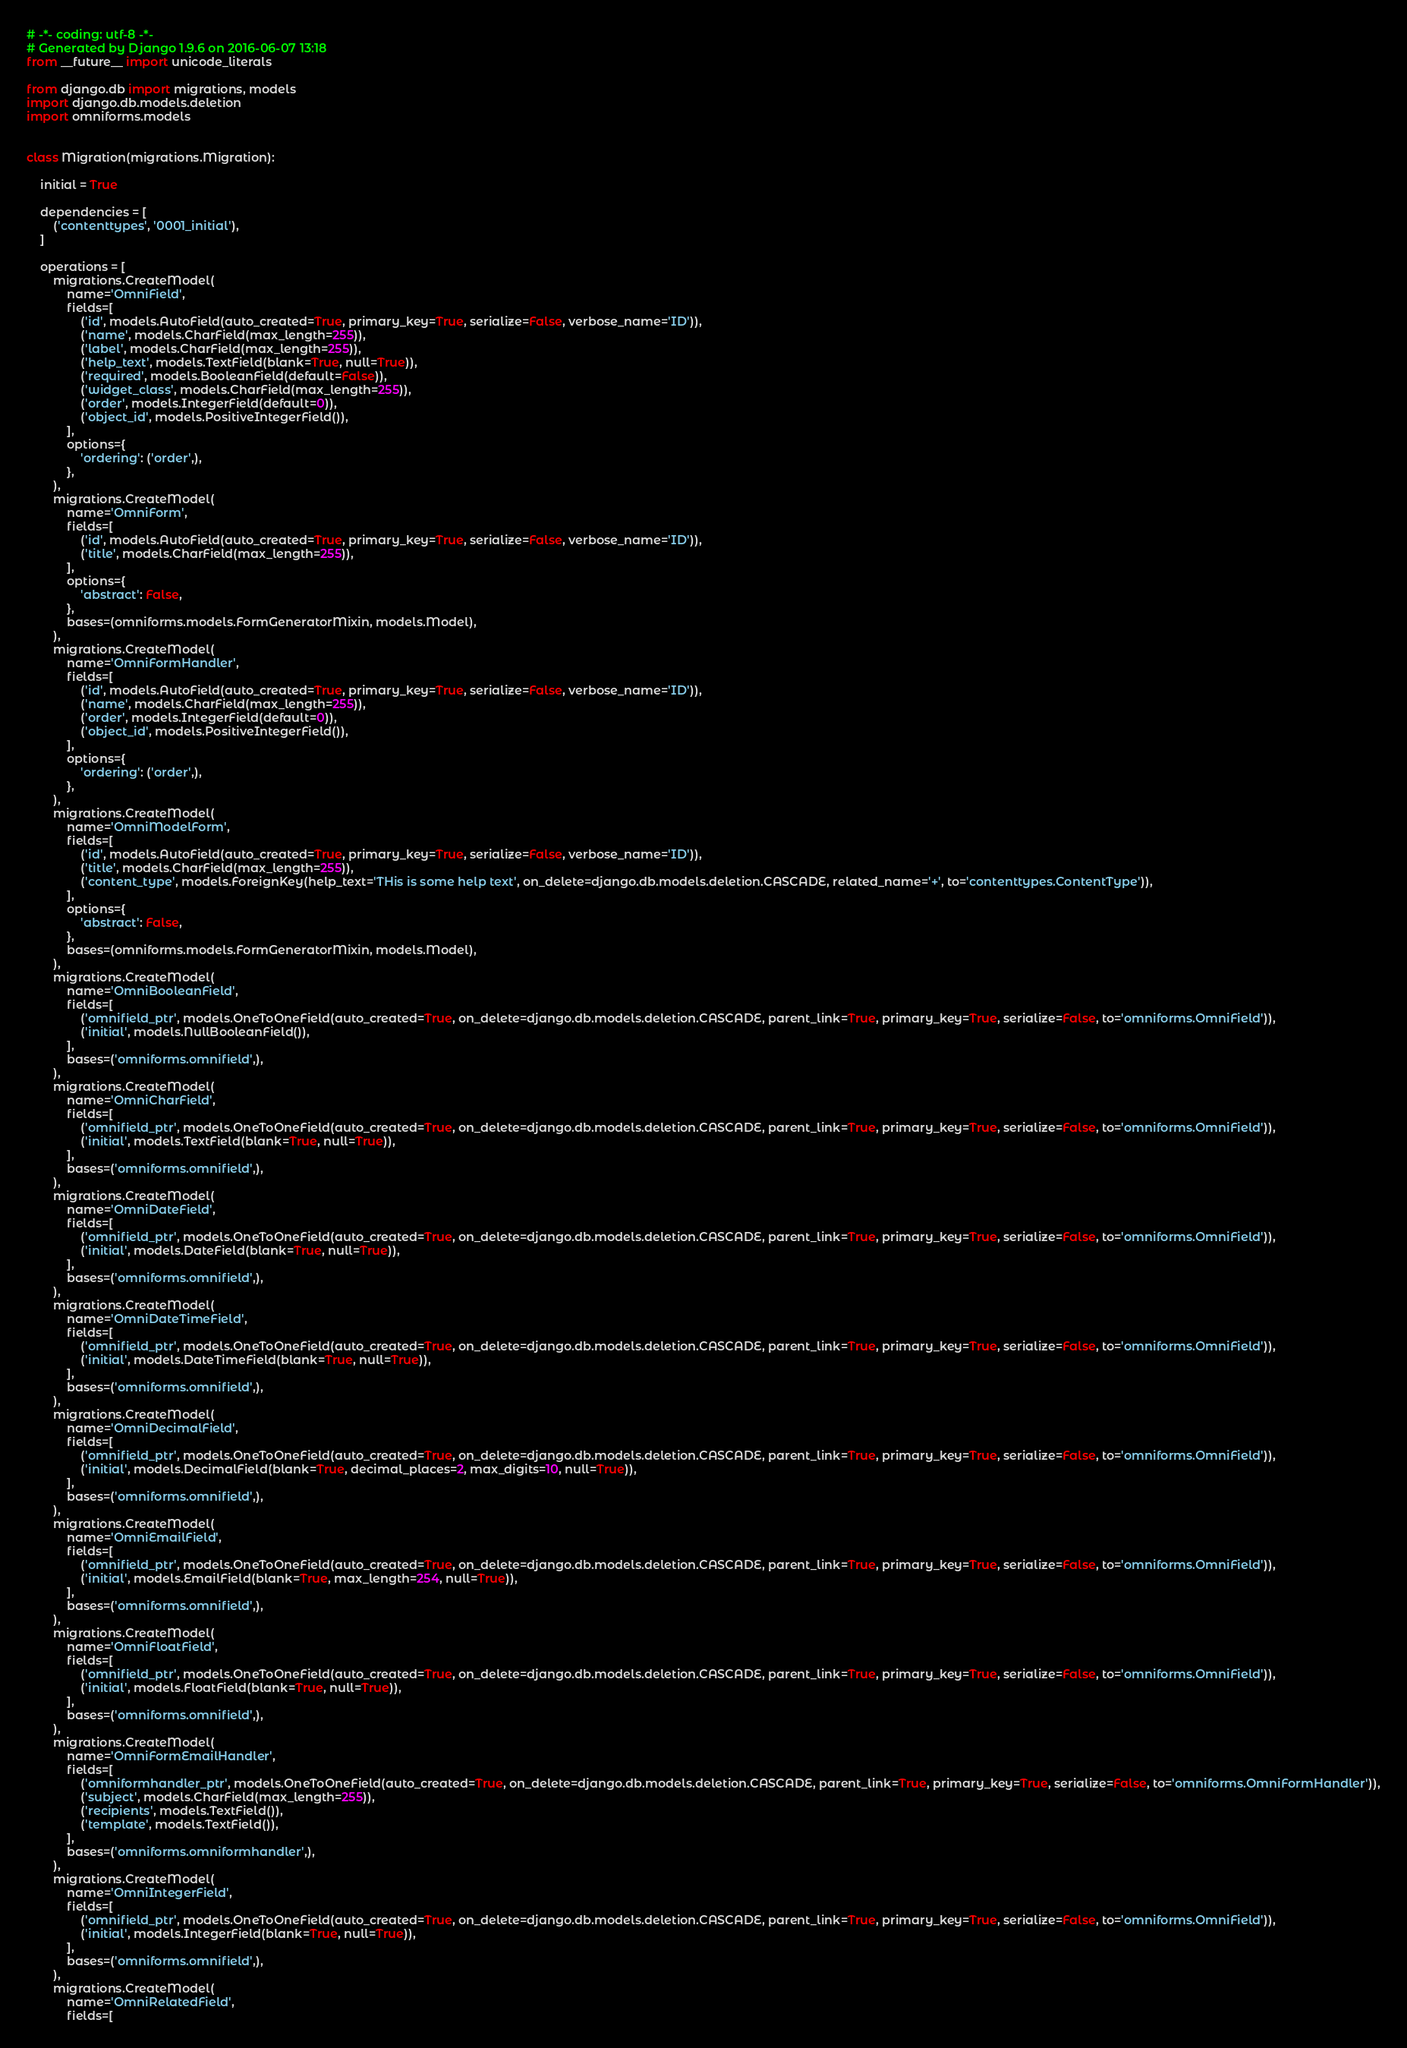Convert code to text. <code><loc_0><loc_0><loc_500><loc_500><_Python_># -*- coding: utf-8 -*-
# Generated by Django 1.9.6 on 2016-06-07 13:18
from __future__ import unicode_literals

from django.db import migrations, models
import django.db.models.deletion
import omniforms.models


class Migration(migrations.Migration):

    initial = True

    dependencies = [
        ('contenttypes', '0001_initial'),
    ]

    operations = [
        migrations.CreateModel(
            name='OmniField',
            fields=[
                ('id', models.AutoField(auto_created=True, primary_key=True, serialize=False, verbose_name='ID')),
                ('name', models.CharField(max_length=255)),
                ('label', models.CharField(max_length=255)),
                ('help_text', models.TextField(blank=True, null=True)),
                ('required', models.BooleanField(default=False)),
                ('widget_class', models.CharField(max_length=255)),
                ('order', models.IntegerField(default=0)),
                ('object_id', models.PositiveIntegerField()),
            ],
            options={
                'ordering': ('order',),
            },
        ),
        migrations.CreateModel(
            name='OmniForm',
            fields=[
                ('id', models.AutoField(auto_created=True, primary_key=True, serialize=False, verbose_name='ID')),
                ('title', models.CharField(max_length=255)),
            ],
            options={
                'abstract': False,
            },
            bases=(omniforms.models.FormGeneratorMixin, models.Model),
        ),
        migrations.CreateModel(
            name='OmniFormHandler',
            fields=[
                ('id', models.AutoField(auto_created=True, primary_key=True, serialize=False, verbose_name='ID')),
                ('name', models.CharField(max_length=255)),
                ('order', models.IntegerField(default=0)),
                ('object_id', models.PositiveIntegerField()),
            ],
            options={
                'ordering': ('order',),
            },
        ),
        migrations.CreateModel(
            name='OmniModelForm',
            fields=[
                ('id', models.AutoField(auto_created=True, primary_key=True, serialize=False, verbose_name='ID')),
                ('title', models.CharField(max_length=255)),
                ('content_type', models.ForeignKey(help_text='THis is some help text', on_delete=django.db.models.deletion.CASCADE, related_name='+', to='contenttypes.ContentType')),
            ],
            options={
                'abstract': False,
            },
            bases=(omniforms.models.FormGeneratorMixin, models.Model),
        ),
        migrations.CreateModel(
            name='OmniBooleanField',
            fields=[
                ('omnifield_ptr', models.OneToOneField(auto_created=True, on_delete=django.db.models.deletion.CASCADE, parent_link=True, primary_key=True, serialize=False, to='omniforms.OmniField')),
                ('initial', models.NullBooleanField()),
            ],
            bases=('omniforms.omnifield',),
        ),
        migrations.CreateModel(
            name='OmniCharField',
            fields=[
                ('omnifield_ptr', models.OneToOneField(auto_created=True, on_delete=django.db.models.deletion.CASCADE, parent_link=True, primary_key=True, serialize=False, to='omniforms.OmniField')),
                ('initial', models.TextField(blank=True, null=True)),
            ],
            bases=('omniforms.omnifield',),
        ),
        migrations.CreateModel(
            name='OmniDateField',
            fields=[
                ('omnifield_ptr', models.OneToOneField(auto_created=True, on_delete=django.db.models.deletion.CASCADE, parent_link=True, primary_key=True, serialize=False, to='omniforms.OmniField')),
                ('initial', models.DateField(blank=True, null=True)),
            ],
            bases=('omniforms.omnifield',),
        ),
        migrations.CreateModel(
            name='OmniDateTimeField',
            fields=[
                ('omnifield_ptr', models.OneToOneField(auto_created=True, on_delete=django.db.models.deletion.CASCADE, parent_link=True, primary_key=True, serialize=False, to='omniforms.OmniField')),
                ('initial', models.DateTimeField(blank=True, null=True)),
            ],
            bases=('omniforms.omnifield',),
        ),
        migrations.CreateModel(
            name='OmniDecimalField',
            fields=[
                ('omnifield_ptr', models.OneToOneField(auto_created=True, on_delete=django.db.models.deletion.CASCADE, parent_link=True, primary_key=True, serialize=False, to='omniforms.OmniField')),
                ('initial', models.DecimalField(blank=True, decimal_places=2, max_digits=10, null=True)),
            ],
            bases=('omniforms.omnifield',),
        ),
        migrations.CreateModel(
            name='OmniEmailField',
            fields=[
                ('omnifield_ptr', models.OneToOneField(auto_created=True, on_delete=django.db.models.deletion.CASCADE, parent_link=True, primary_key=True, serialize=False, to='omniforms.OmniField')),
                ('initial', models.EmailField(blank=True, max_length=254, null=True)),
            ],
            bases=('omniforms.omnifield',),
        ),
        migrations.CreateModel(
            name='OmniFloatField',
            fields=[
                ('omnifield_ptr', models.OneToOneField(auto_created=True, on_delete=django.db.models.deletion.CASCADE, parent_link=True, primary_key=True, serialize=False, to='omniforms.OmniField')),
                ('initial', models.FloatField(blank=True, null=True)),
            ],
            bases=('omniforms.omnifield',),
        ),
        migrations.CreateModel(
            name='OmniFormEmailHandler',
            fields=[
                ('omniformhandler_ptr', models.OneToOneField(auto_created=True, on_delete=django.db.models.deletion.CASCADE, parent_link=True, primary_key=True, serialize=False, to='omniforms.OmniFormHandler')),
                ('subject', models.CharField(max_length=255)),
                ('recipients', models.TextField()),
                ('template', models.TextField()),
            ],
            bases=('omniforms.omniformhandler',),
        ),
        migrations.CreateModel(
            name='OmniIntegerField',
            fields=[
                ('omnifield_ptr', models.OneToOneField(auto_created=True, on_delete=django.db.models.deletion.CASCADE, parent_link=True, primary_key=True, serialize=False, to='omniforms.OmniField')),
                ('initial', models.IntegerField(blank=True, null=True)),
            ],
            bases=('omniforms.omnifield',),
        ),
        migrations.CreateModel(
            name='OmniRelatedField',
            fields=[</code> 